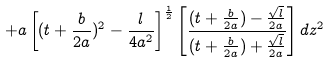<formula> <loc_0><loc_0><loc_500><loc_500>+ a \left [ ( t + \frac { b } { 2 a } ) ^ { 2 } - \frac { l } { 4 a ^ { 2 } } \right ] ^ { \frac { 1 } { 2 } } \left [ \frac { ( t + \frac { b } { 2 a } ) - \frac { \sqrt { l } } { 2 a } } { ( t + \frac { b } { 2 a } ) + \frac { \sqrt { l } } { 2 a } } \right ] d z ^ { 2 }</formula> 